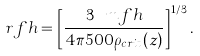<formula> <loc_0><loc_0><loc_500><loc_500>\ r f h = \left [ \frac { 3 \ m f h } { 4 \pi 5 0 0 \rho _ { c r i t } ( z ) } \right ] ^ { 1 / 3 } .</formula> 